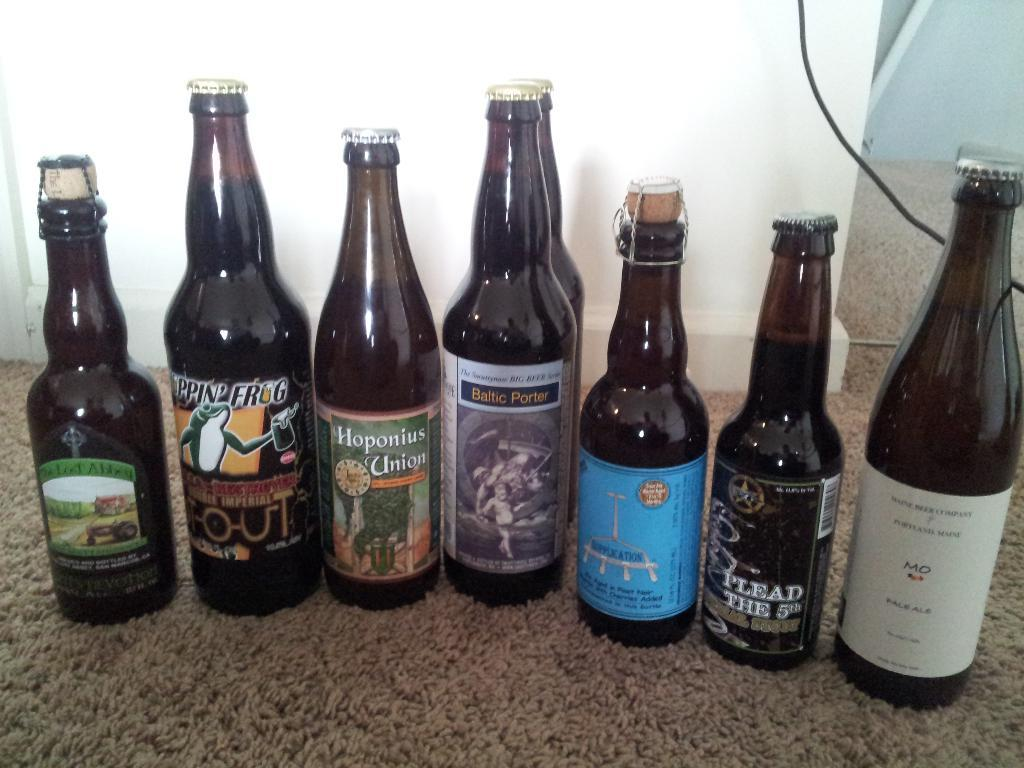<image>
Create a compact narrative representing the image presented. A bottle of pale ale positioned to the right of six other bottles. 